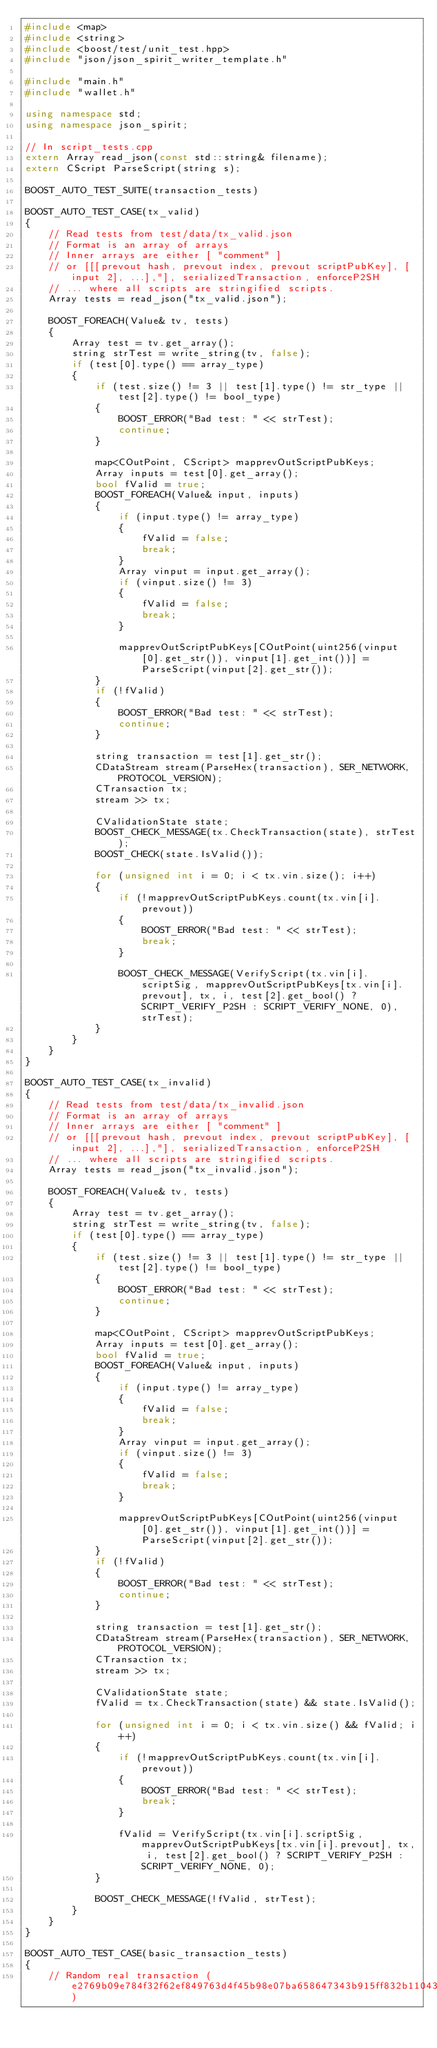<code> <loc_0><loc_0><loc_500><loc_500><_C++_>#include <map>
#include <string>
#include <boost/test/unit_test.hpp>
#include "json/json_spirit_writer_template.h"

#include "main.h"
#include "wallet.h"

using namespace std;
using namespace json_spirit;

// In script_tests.cpp
extern Array read_json(const std::string& filename);
extern CScript ParseScript(string s);

BOOST_AUTO_TEST_SUITE(transaction_tests)

BOOST_AUTO_TEST_CASE(tx_valid)
{
    // Read tests from test/data/tx_valid.json
    // Format is an array of arrays
    // Inner arrays are either [ "comment" ]
    // or [[[prevout hash, prevout index, prevout scriptPubKey], [input 2], ...],"], serializedTransaction, enforceP2SH
    // ... where all scripts are stringified scripts.
    Array tests = read_json("tx_valid.json");

    BOOST_FOREACH(Value& tv, tests)
    {
        Array test = tv.get_array();
        string strTest = write_string(tv, false);
        if (test[0].type() == array_type)
        {
            if (test.size() != 3 || test[1].type() != str_type || test[2].type() != bool_type)
            {
                BOOST_ERROR("Bad test: " << strTest);
                continue;
            }

            map<COutPoint, CScript> mapprevOutScriptPubKeys;
            Array inputs = test[0].get_array();
            bool fValid = true;
            BOOST_FOREACH(Value& input, inputs)
            {
                if (input.type() != array_type)
                {
                    fValid = false;
                    break;
                }
                Array vinput = input.get_array();
                if (vinput.size() != 3)
                {
                    fValid = false;
                    break;
                }

                mapprevOutScriptPubKeys[COutPoint(uint256(vinput[0].get_str()), vinput[1].get_int())] = ParseScript(vinput[2].get_str());
            }
            if (!fValid)
            {
                BOOST_ERROR("Bad test: " << strTest);
                continue;
            }

            string transaction = test[1].get_str();
            CDataStream stream(ParseHex(transaction), SER_NETWORK, PROTOCOL_VERSION);
            CTransaction tx;
            stream >> tx;

            CValidationState state;
            BOOST_CHECK_MESSAGE(tx.CheckTransaction(state), strTest);
            BOOST_CHECK(state.IsValid());

            for (unsigned int i = 0; i < tx.vin.size(); i++)
            {
                if (!mapprevOutScriptPubKeys.count(tx.vin[i].prevout))
                {
                    BOOST_ERROR("Bad test: " << strTest);
                    break;
                }

                BOOST_CHECK_MESSAGE(VerifyScript(tx.vin[i].scriptSig, mapprevOutScriptPubKeys[tx.vin[i].prevout], tx, i, test[2].get_bool() ? SCRIPT_VERIFY_P2SH : SCRIPT_VERIFY_NONE, 0), strTest);
            }
        }
    }
}

BOOST_AUTO_TEST_CASE(tx_invalid)
{
    // Read tests from test/data/tx_invalid.json
    // Format is an array of arrays
    // Inner arrays are either [ "comment" ]
    // or [[[prevout hash, prevout index, prevout scriptPubKey], [input 2], ...],"], serializedTransaction, enforceP2SH
    // ... where all scripts are stringified scripts.
    Array tests = read_json("tx_invalid.json");

    BOOST_FOREACH(Value& tv, tests)
    {
        Array test = tv.get_array();
        string strTest = write_string(tv, false);
        if (test[0].type() == array_type)
        {
            if (test.size() != 3 || test[1].type() != str_type || test[2].type() != bool_type)
            {
                BOOST_ERROR("Bad test: " << strTest);
                continue;
            }

            map<COutPoint, CScript> mapprevOutScriptPubKeys;
            Array inputs = test[0].get_array();
            bool fValid = true;
            BOOST_FOREACH(Value& input, inputs)
            {
                if (input.type() != array_type)
                {
                    fValid = false;
                    break;
                }
                Array vinput = input.get_array();
                if (vinput.size() != 3)
                {
                    fValid = false;
                    break;
                }

                mapprevOutScriptPubKeys[COutPoint(uint256(vinput[0].get_str()), vinput[1].get_int())] = ParseScript(vinput[2].get_str());
            }
            if (!fValid)
            {
                BOOST_ERROR("Bad test: " << strTest);
                continue;
            }

            string transaction = test[1].get_str();
            CDataStream stream(ParseHex(transaction), SER_NETWORK, PROTOCOL_VERSION);
            CTransaction tx;
            stream >> tx;

            CValidationState state;
            fValid = tx.CheckTransaction(state) && state.IsValid();

            for (unsigned int i = 0; i < tx.vin.size() && fValid; i++)
            {
                if (!mapprevOutScriptPubKeys.count(tx.vin[i].prevout))
                {
                    BOOST_ERROR("Bad test: " << strTest);
                    break;
                }

                fValid = VerifyScript(tx.vin[i].scriptSig, mapprevOutScriptPubKeys[tx.vin[i].prevout], tx, i, test[2].get_bool() ? SCRIPT_VERIFY_P2SH : SCRIPT_VERIFY_NONE, 0);
            }

            BOOST_CHECK_MESSAGE(!fValid, strTest);
        }
    }
}

BOOST_AUTO_TEST_CASE(basic_transaction_tests)
{
    // Random real transaction (e2769b09e784f32f62ef849763d4f45b98e07ba658647343b915ff832b110436)</code> 